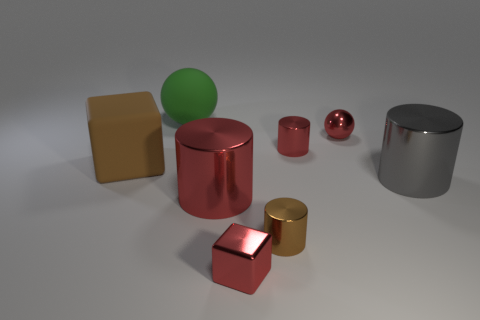How many red cylinders must be subtracted to get 1 red cylinders? 1 Add 1 big matte balls. How many objects exist? 9 Subtract all balls. How many objects are left? 6 Add 3 red spheres. How many red spheres are left? 4 Add 8 matte balls. How many matte balls exist? 9 Subtract 0 gray blocks. How many objects are left? 8 Subtract all brown cylinders. Subtract all cyan matte things. How many objects are left? 7 